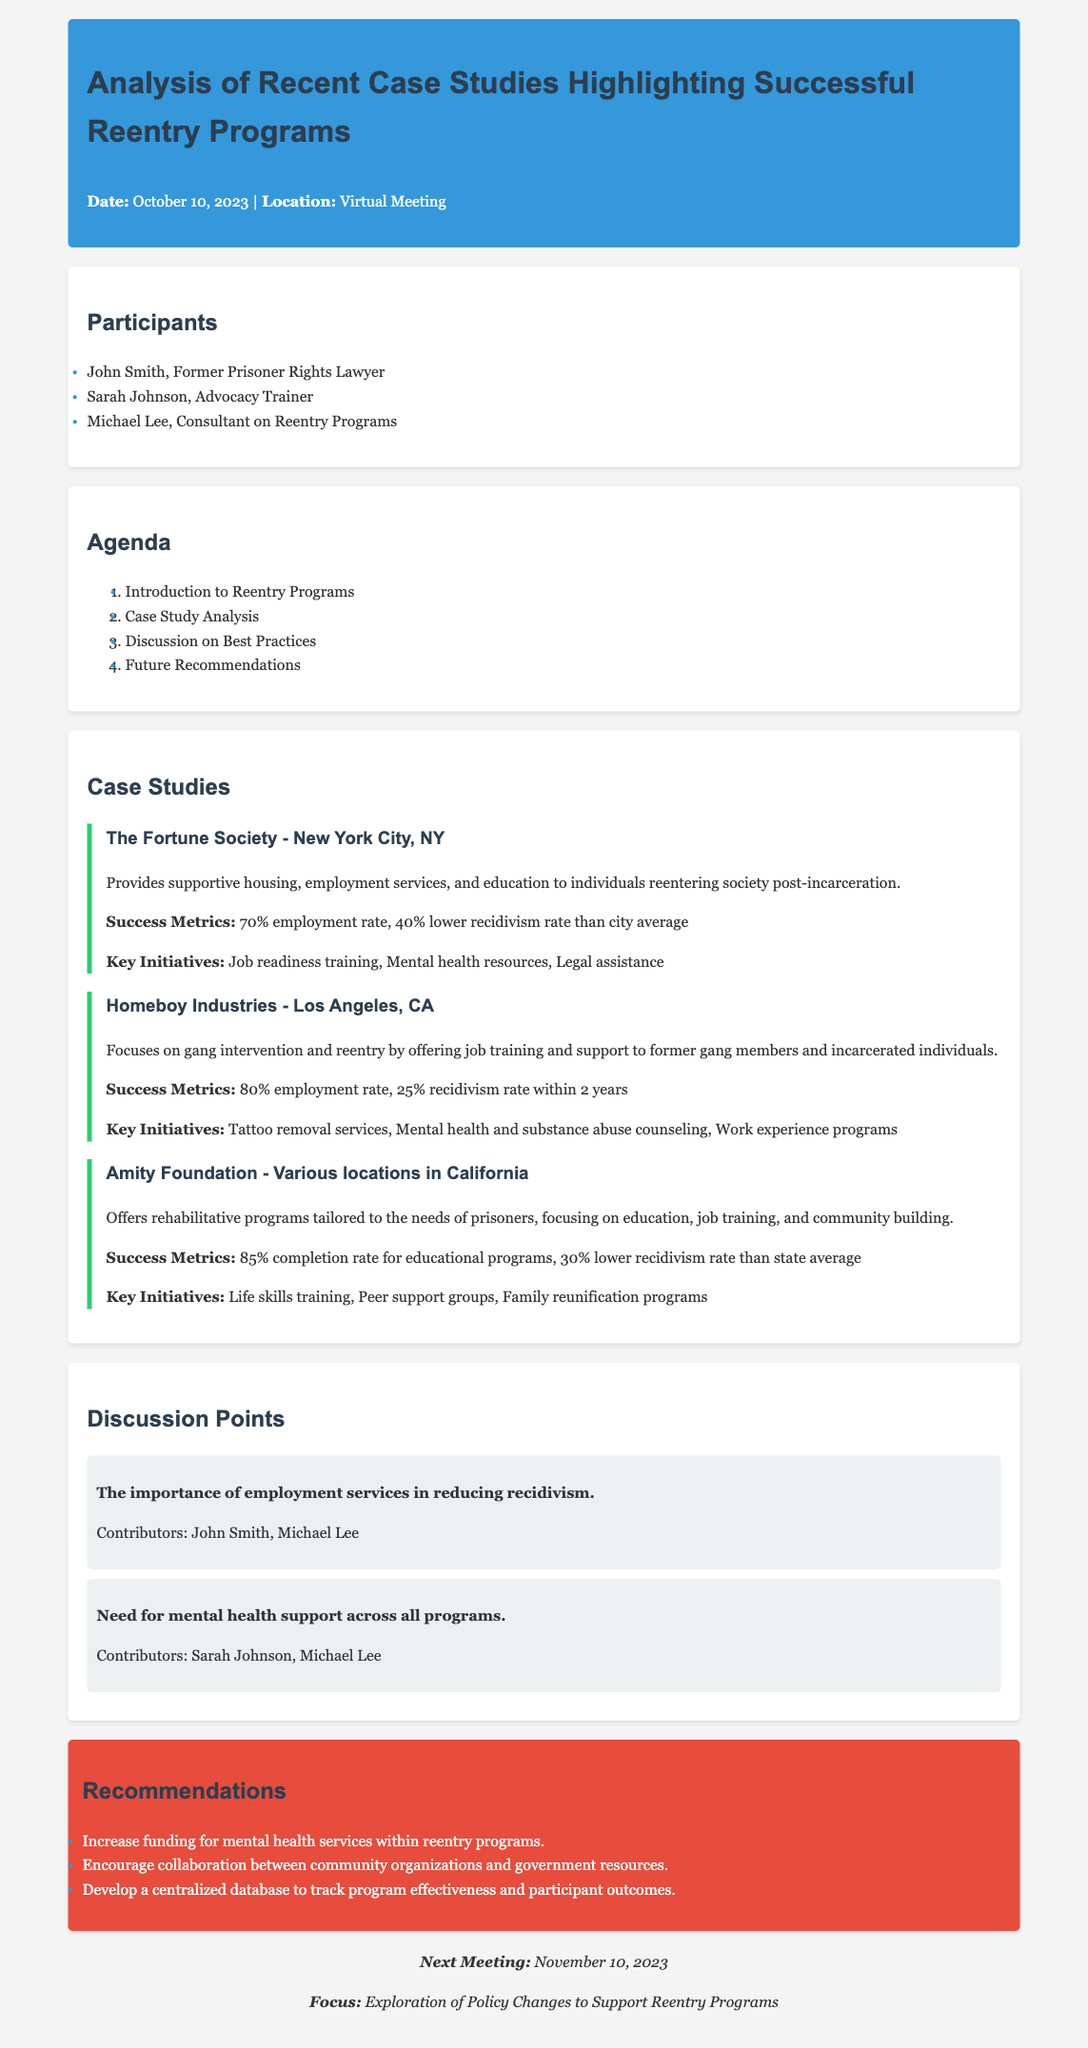What is the date of the meeting? The date of the meeting is mentioned in the header section of the document.
Answer: October 10, 2023 Who is one of the participants listed in the meeting? The participants are listed in the second section of the document.
Answer: John Smith What is the employment rate achieved by the Fortune Society? The success metrics for the Fortune Society are specified in its case study section.
Answer: 70% employment rate What is one key initiative of Homeboy Industries? The key initiatives of Homeboy Industries are listed in the corresponding case study section.
Answer: Tattoo removal services What is the next meeting's focus? The focus for the next meeting is found in the next meeting section at the end of the document.
Answer: Exploration of Policy Changes to Support Reentry Programs What is the recidivism rate reduction reported by Amity Foundation? The recidivism rate reduction for Amity Foundation is part of its success metrics in the document.
Answer: 30% lower recidivism rate than state average Who contributed to the discussion on the importance of employment services? The contributors to the discussion points can be found in the discussion section of the document.
Answer: John Smith, Michael Lee What type of program does the Amity Foundation offer? The type of program offered by Amity Foundation is mentioned in its case study section.
Answer: Rehabilitative programs What is one of the recommended actions from the meeting? The recommendations are listed at the end of the document, specifically in the recommendations section.
Answer: Increase funding for mental health services within reentry programs 